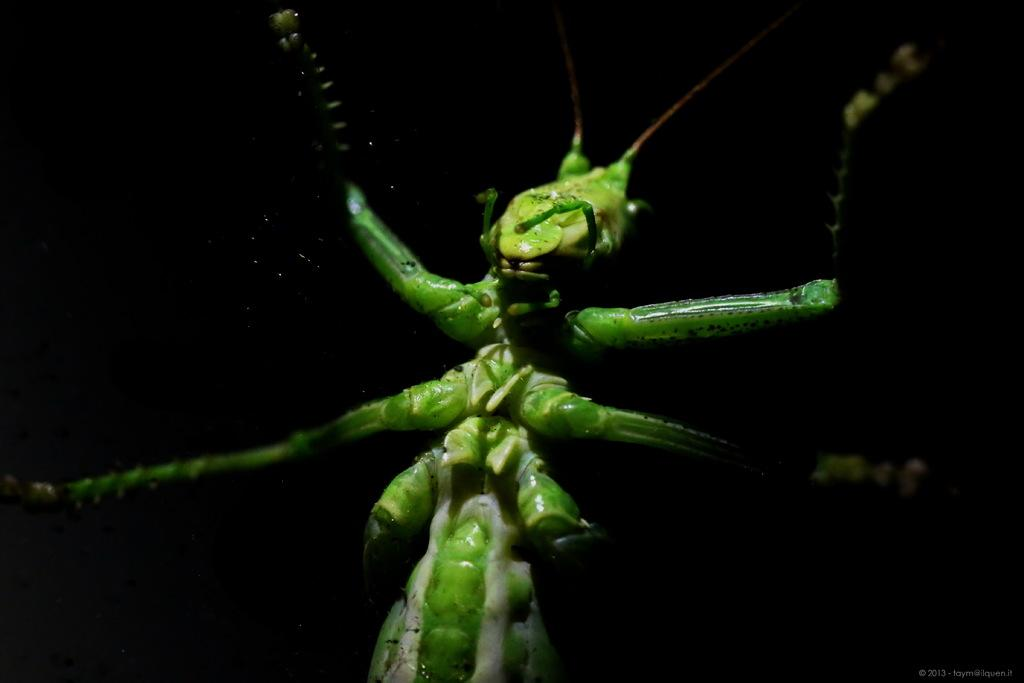What type of living organism can be seen in the image? There is an insect in the image. What else is present at the bottom of the image? There is some text at the bottom of the image. What type of song is the secretary offering in the image? There is no mention of a secretary or a song in the image; it only features an insect and some text. 